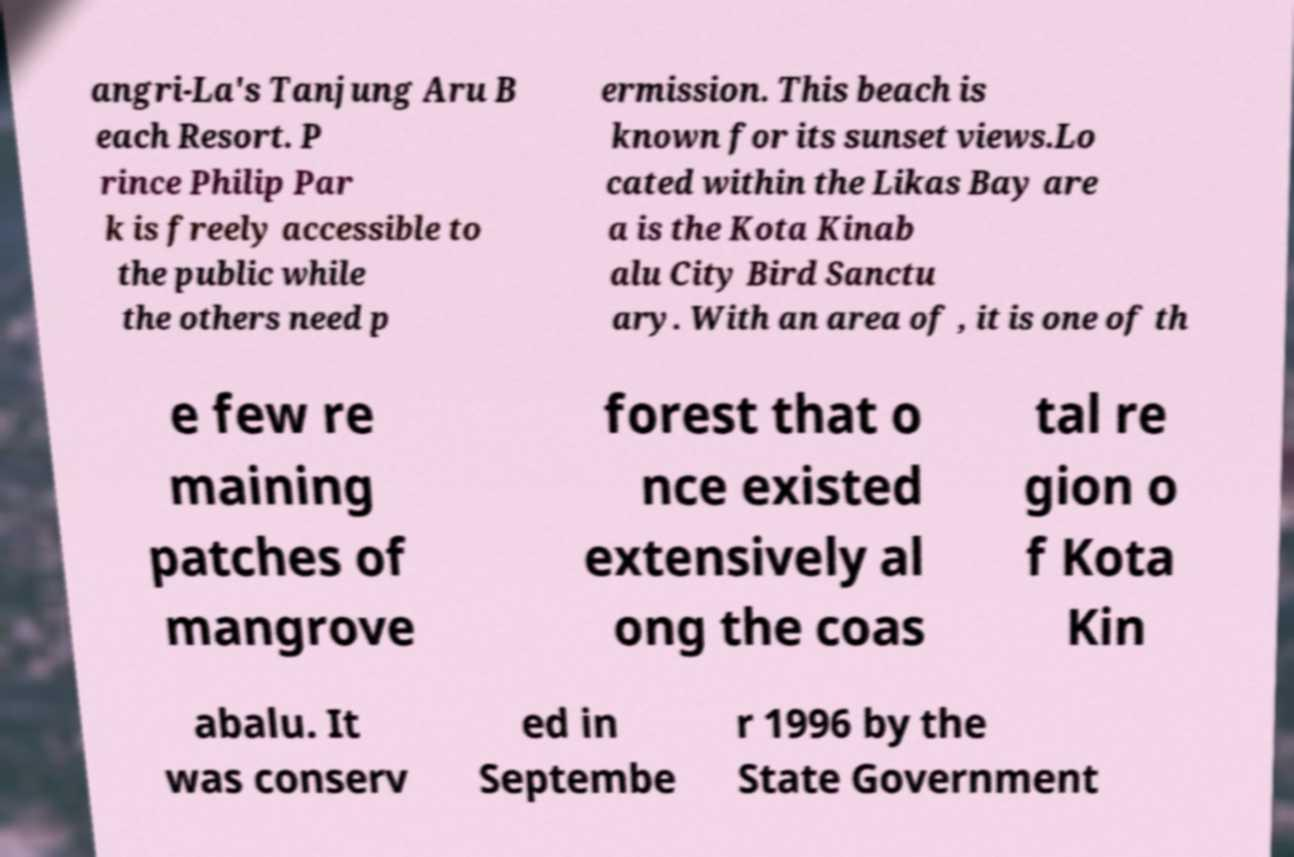Please read and relay the text visible in this image. What does it say? angri-La's Tanjung Aru B each Resort. P rince Philip Par k is freely accessible to the public while the others need p ermission. This beach is known for its sunset views.Lo cated within the Likas Bay are a is the Kota Kinab alu City Bird Sanctu ary. With an area of , it is one of th e few re maining patches of mangrove forest that o nce existed extensively al ong the coas tal re gion o f Kota Kin abalu. It was conserv ed in Septembe r 1996 by the State Government 